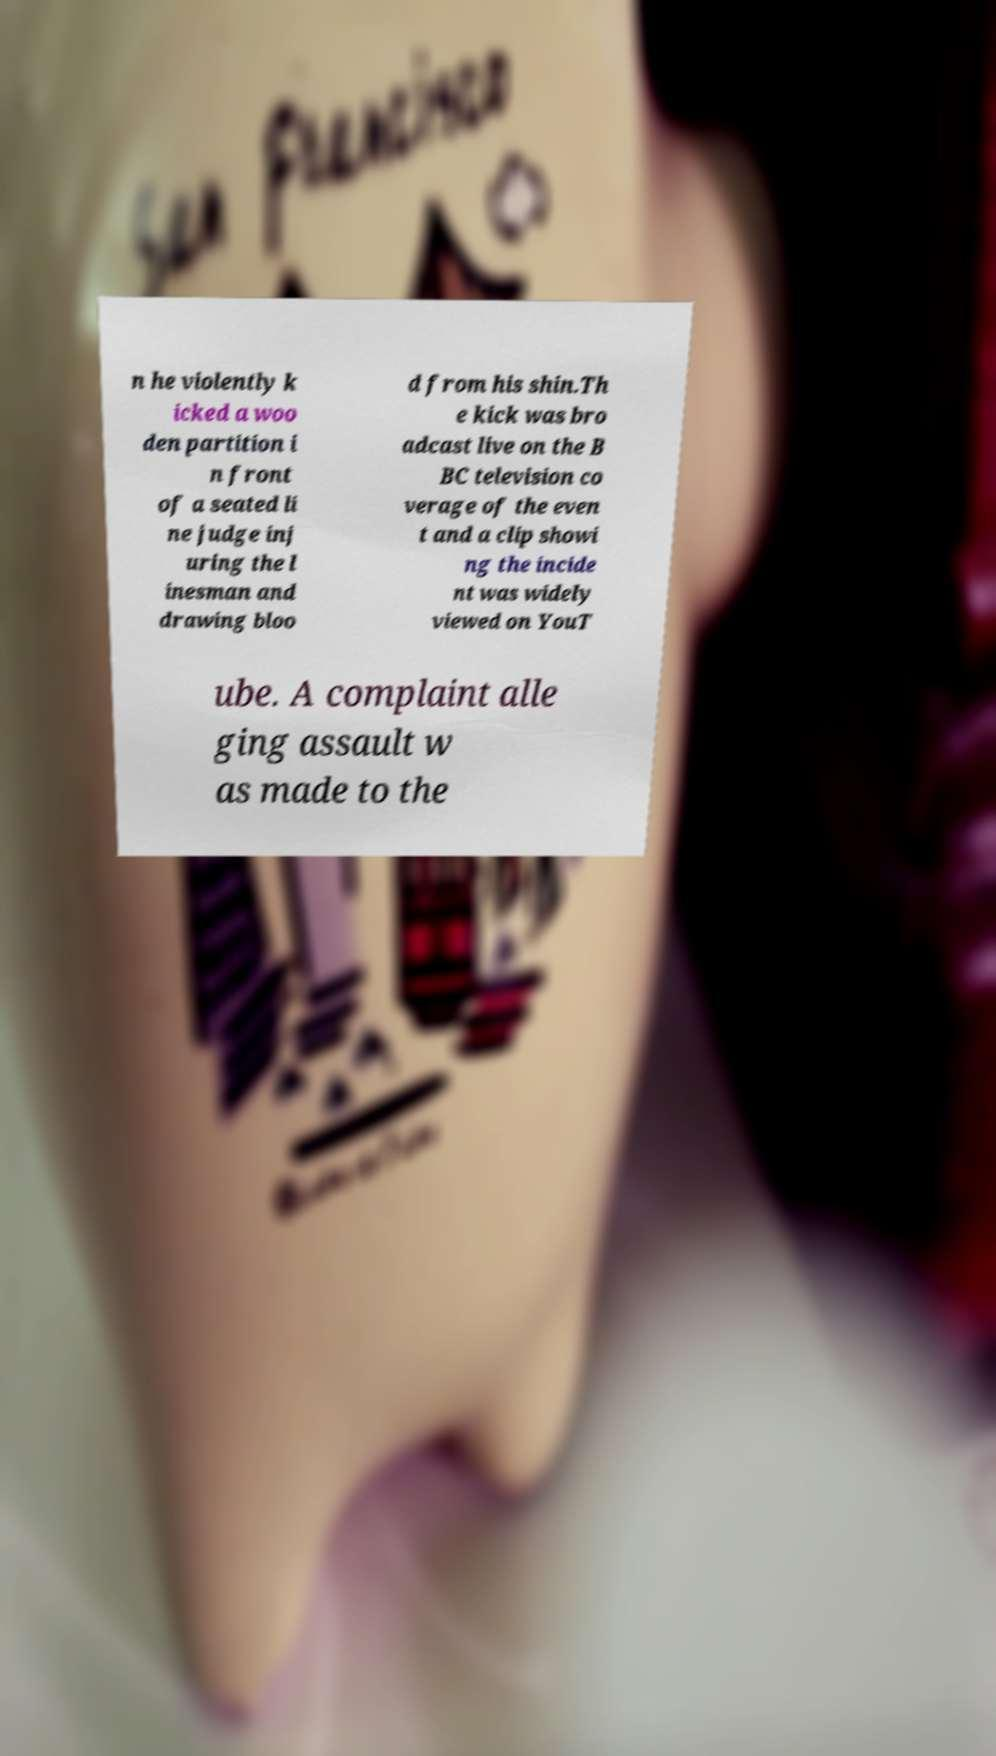Please read and relay the text visible in this image. What does it say? n he violently k icked a woo den partition i n front of a seated li ne judge inj uring the l inesman and drawing bloo d from his shin.Th e kick was bro adcast live on the B BC television co verage of the even t and a clip showi ng the incide nt was widely viewed on YouT ube. A complaint alle ging assault w as made to the 